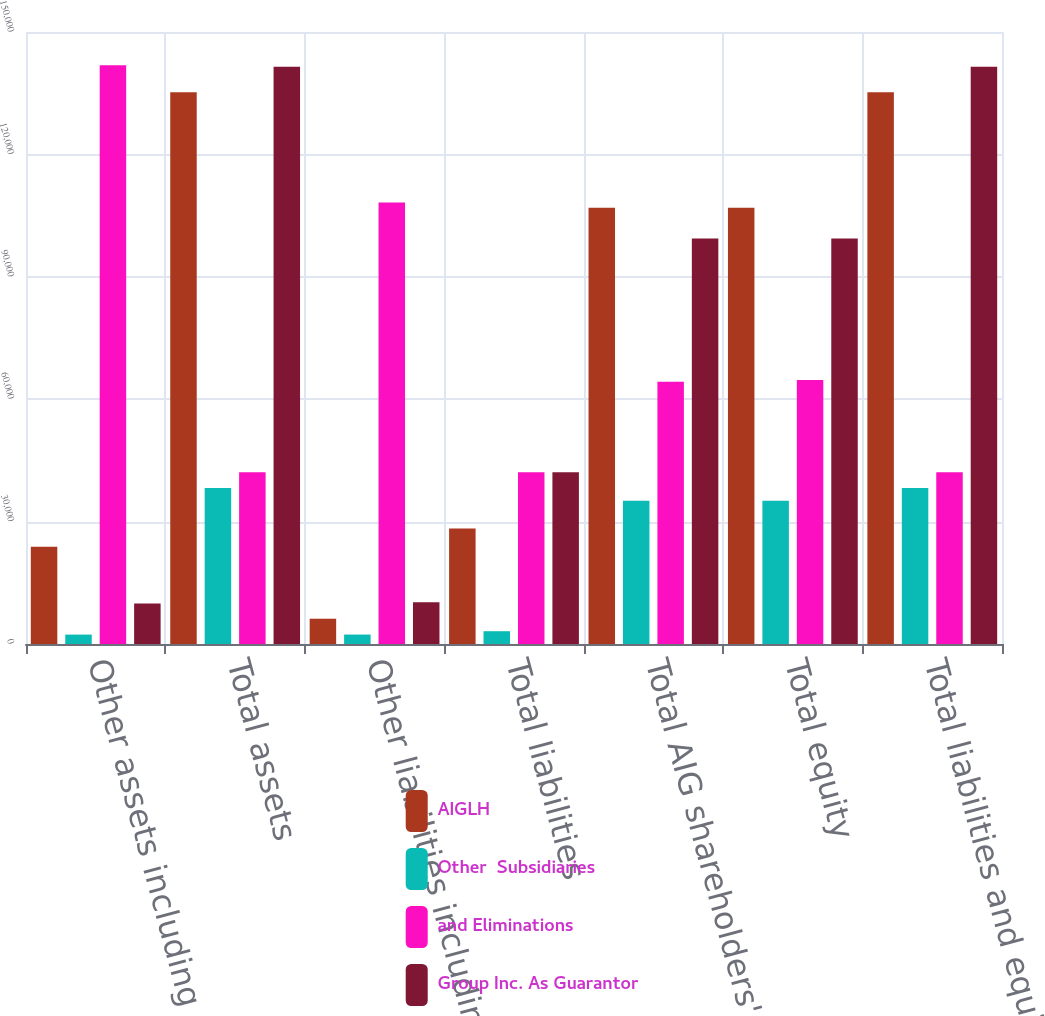Convert chart to OTSL. <chart><loc_0><loc_0><loc_500><loc_500><stacked_bar_chart><ecel><fcel>Other assets including<fcel>Total assets<fcel>Other liabilities including<fcel>Total liabilities<fcel>Total AIG shareholders' equity<fcel>Total equity<fcel>Total liabilities and equity<nl><fcel>AIGLH<fcel>23835<fcel>135235<fcel>6196<fcel>28337<fcel>106898<fcel>106898<fcel>135235<nl><fcel>Other  Subsidiaries<fcel>2305<fcel>38246<fcel>2314<fcel>3134<fcel>35112<fcel>35112<fcel>38246<nl><fcel>and Eliminations<fcel>141826<fcel>42071<fcel>108189<fcel>42071<fcel>64302<fcel>64676<fcel>42071<nl><fcel>Group Inc. As Guarantor<fcel>9909<fcel>141485<fcel>10222<fcel>42071<fcel>99414<fcel>99414<fcel>141485<nl></chart> 